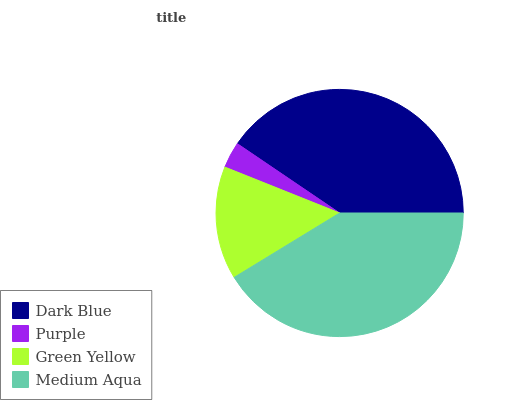Is Purple the minimum?
Answer yes or no. Yes. Is Medium Aqua the maximum?
Answer yes or no. Yes. Is Green Yellow the minimum?
Answer yes or no. No. Is Green Yellow the maximum?
Answer yes or no. No. Is Green Yellow greater than Purple?
Answer yes or no. Yes. Is Purple less than Green Yellow?
Answer yes or no. Yes. Is Purple greater than Green Yellow?
Answer yes or no. No. Is Green Yellow less than Purple?
Answer yes or no. No. Is Dark Blue the high median?
Answer yes or no. Yes. Is Green Yellow the low median?
Answer yes or no. Yes. Is Medium Aqua the high median?
Answer yes or no. No. Is Medium Aqua the low median?
Answer yes or no. No. 